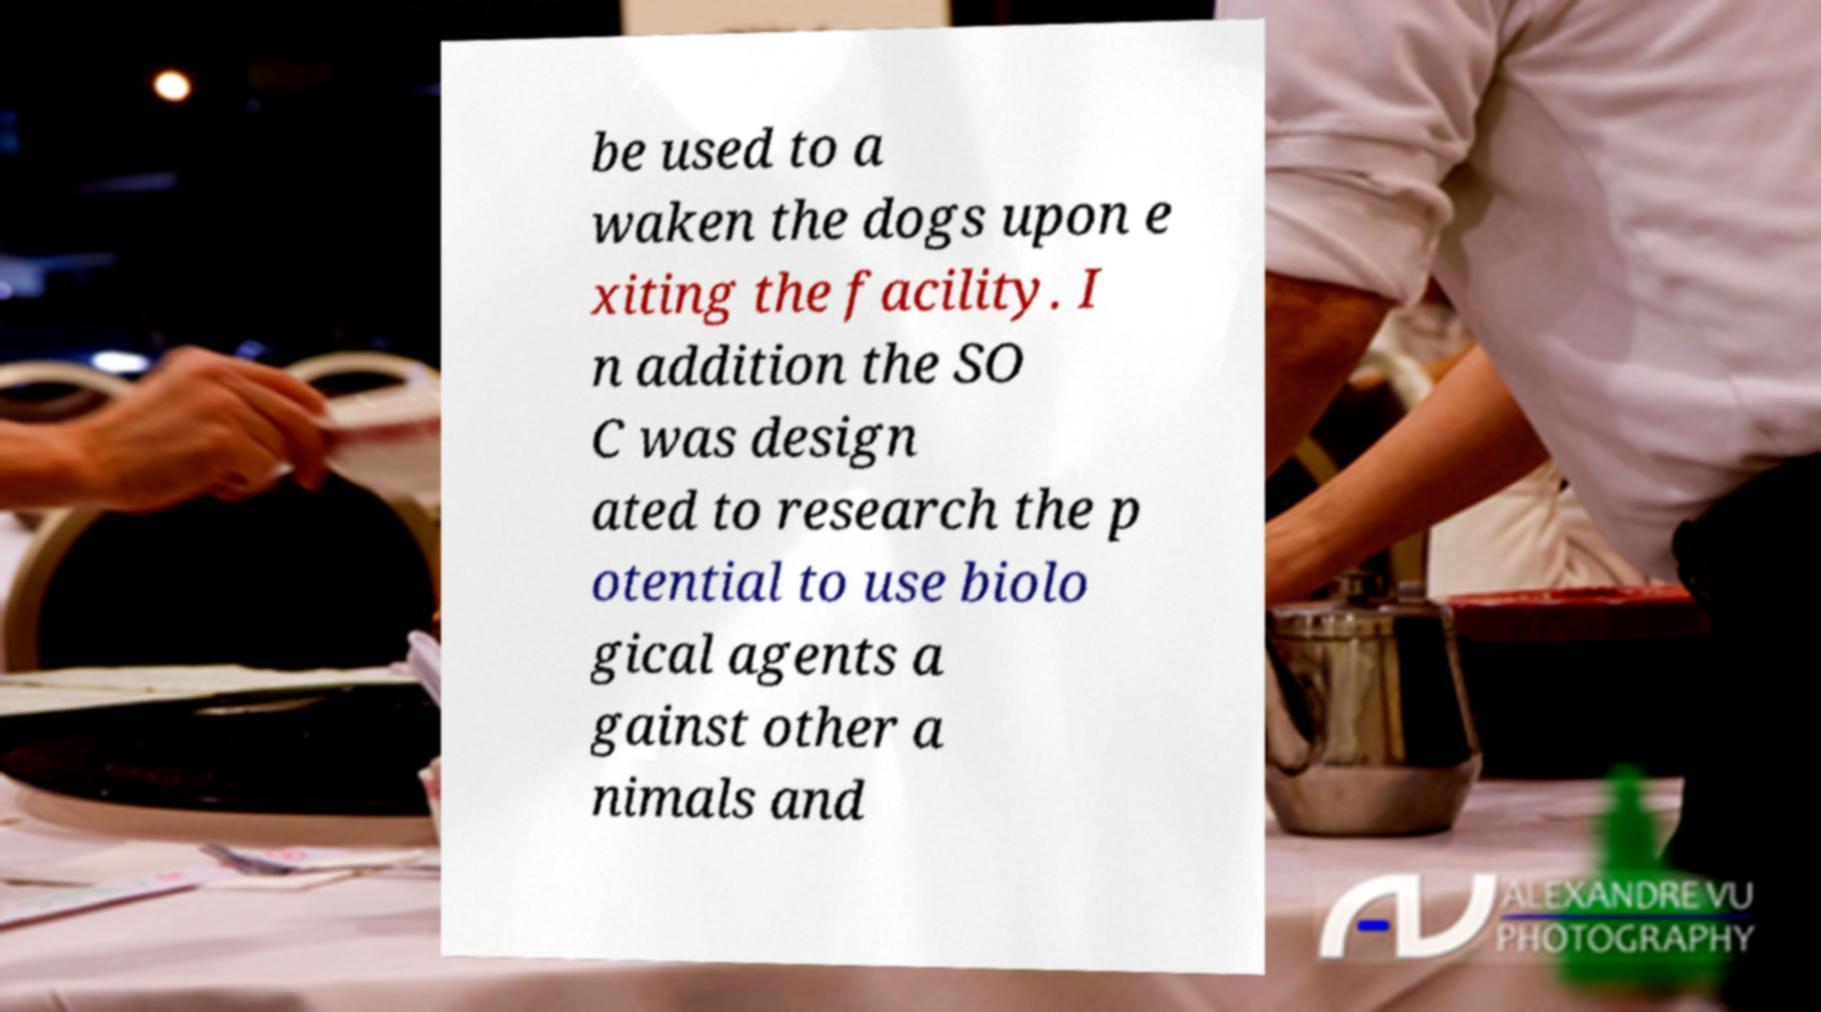There's text embedded in this image that I need extracted. Can you transcribe it verbatim? be used to a waken the dogs upon e xiting the facility. I n addition the SO C was design ated to research the p otential to use biolo gical agents a gainst other a nimals and 